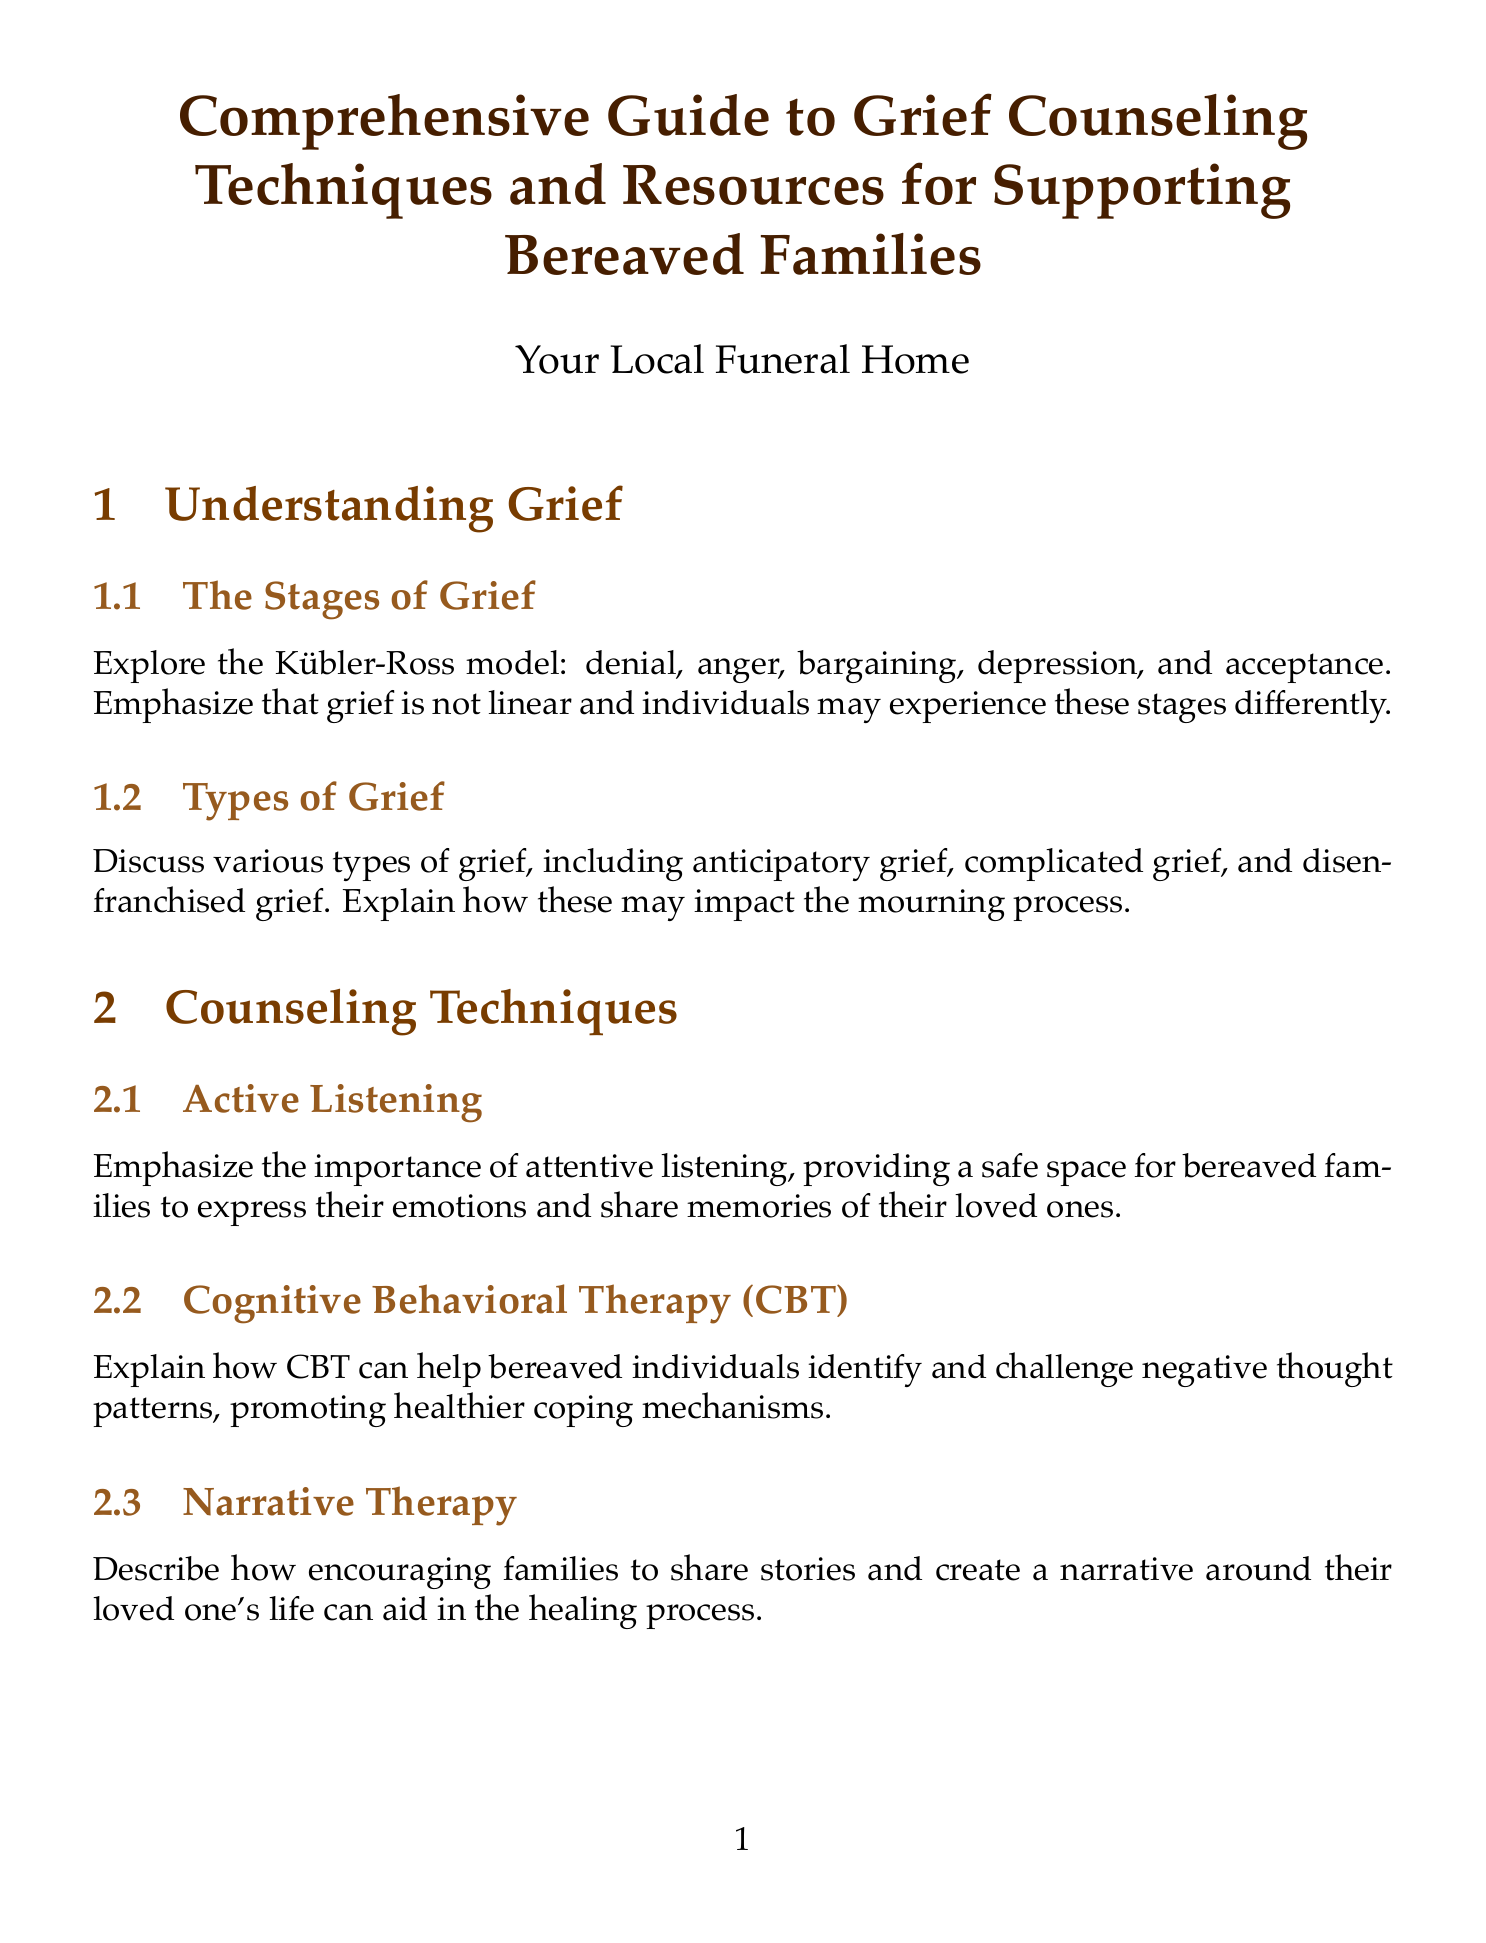what are the stages of grief? The document outlines the Kübler-Ross model which includes denial, anger, bargaining, depression, and acceptance.
Answer: denial, anger, bargaining, depression, acceptance what type of therapy is described for helping bereaved individuals with negative thoughts? The document mentions a specific therapy technique that aids in identifying and challenging negative thought patterns.
Answer: Cognitive Behavioral Therapy (CBT) what is one method suggested for helping children process their grief? The document includes activities to assist young people in processing grief, specifically through creative means.
Answer: art therapy which cultural mourning practice is highlighted for understanding? The document discusses a specific cultural mourning ritual that is significant in Judaism.
Answer: sitting shiva what is a local resource mentioned for grief support? The document lists a specific local organization that offers support for grieving individuals and families.
Answer: Midwest Center for Hope and Healing what is emphasized as a key aspect of effective grief counseling? The document highlights an essential communication technique that aids bereaved families in expressing their emotions.
Answer: Active Listening how often does the document suggest following up with bereaved families? The document outlines a strategy for ongoing communication with families, although it does not specify exact intervals.
Answer: key intervals what is recommended for self-care among grief counselors? The document provides suggestions for maintaining emotional well-being specifically for those working in grief counseling settings.
Answer: mindfulness practices what type of events does the document suggest organizing for ongoing support? The document mentions a type of community event that can provide continued support for grieving families.
Answer: annual remembrance services 